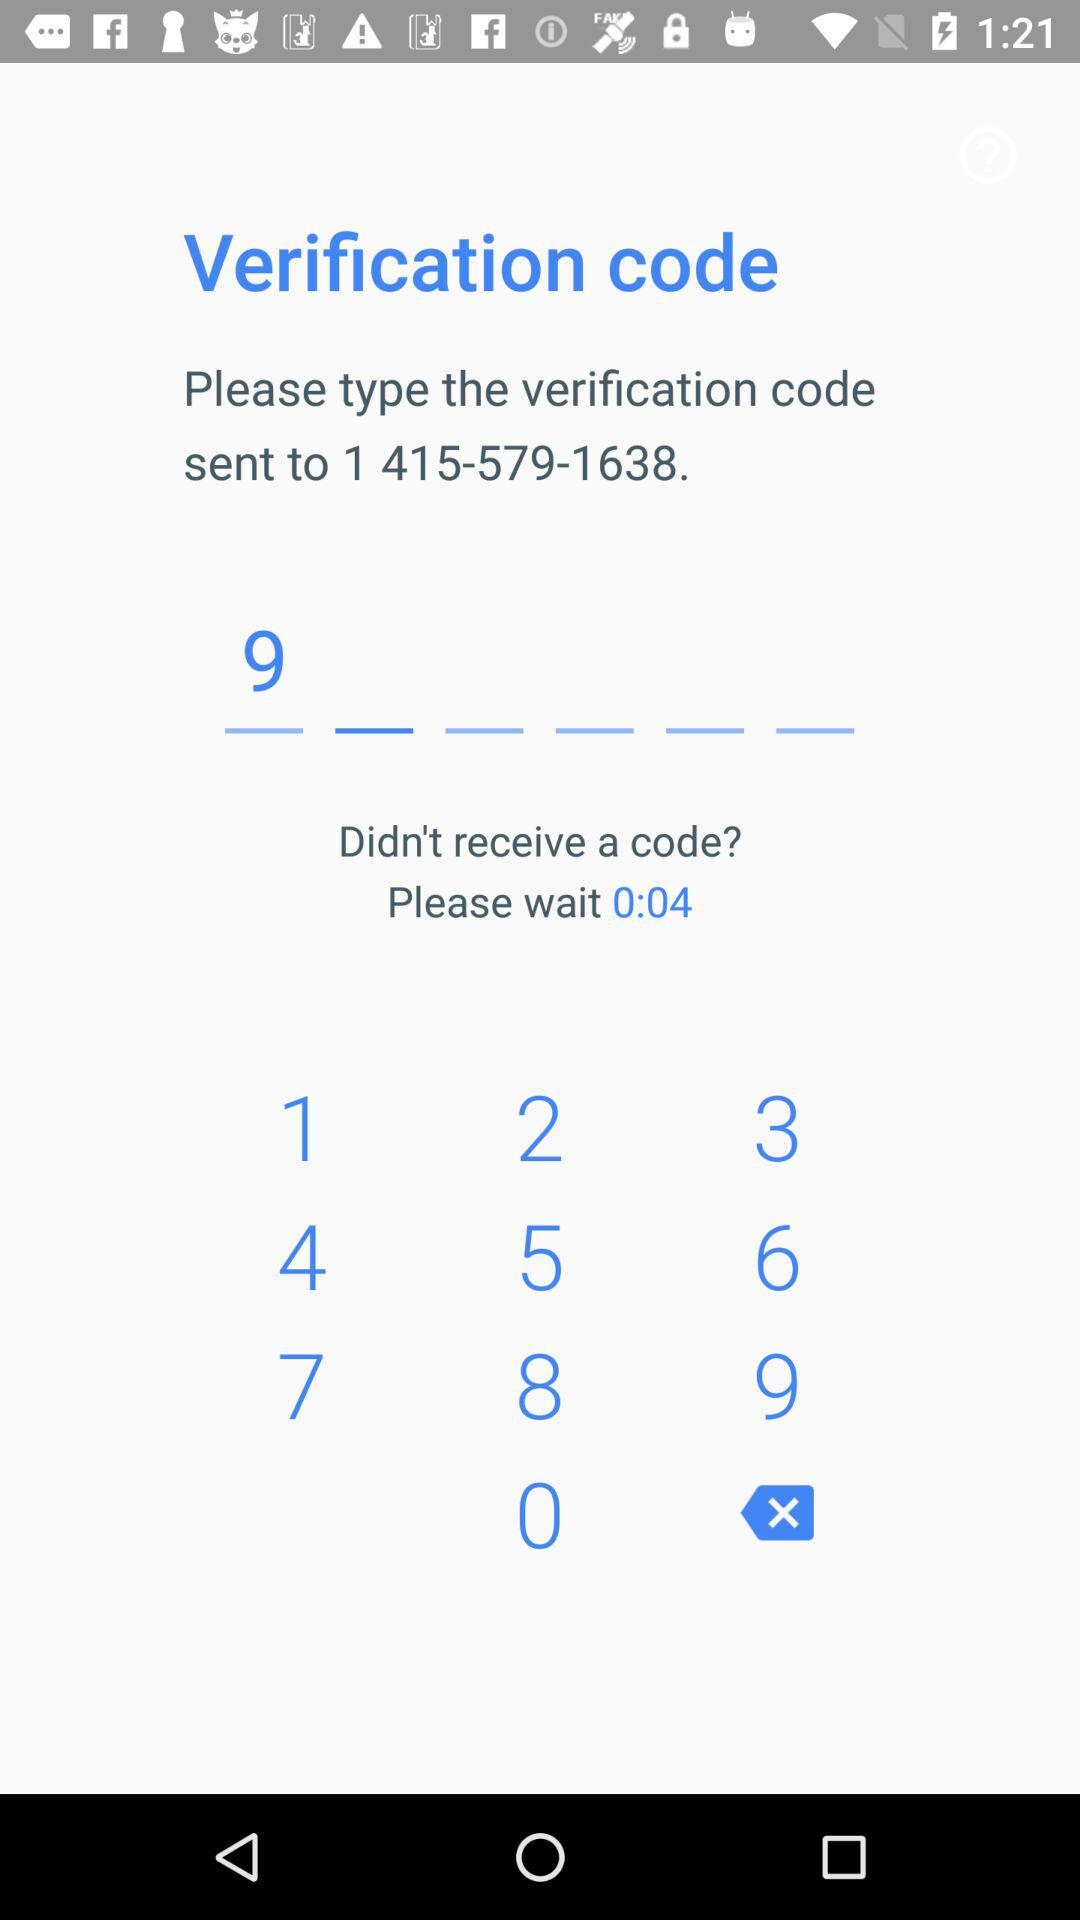How long does one have to wait to resend the code? One has to wait 4 seconds to resend the code. 